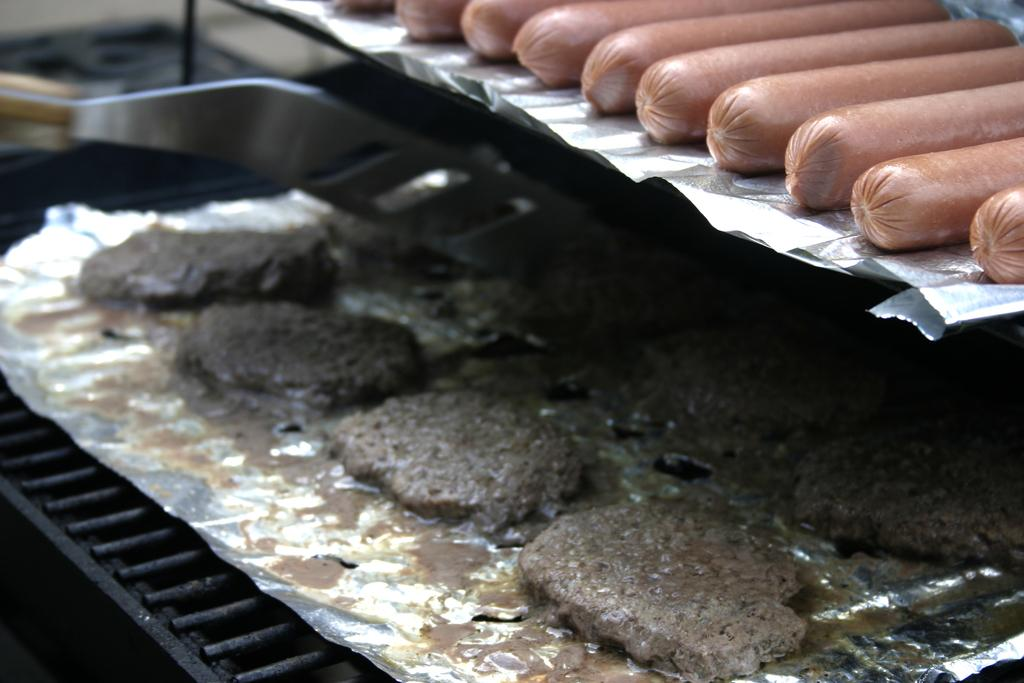What type of food can be seen on the aluminium foil in the image? There are sausages on the aluminium foil in the image. Are there any other food items visible on the aluminium foil? Yes, there is another food item on the aluminium foil in the image. Where are the food items located in the image? The food items are on a grill. What can be seen in the background of the image? There are objects visible in the background of the image. Can you see a deer's face in the image? There is no deer or any part of a deer visible in the image. 